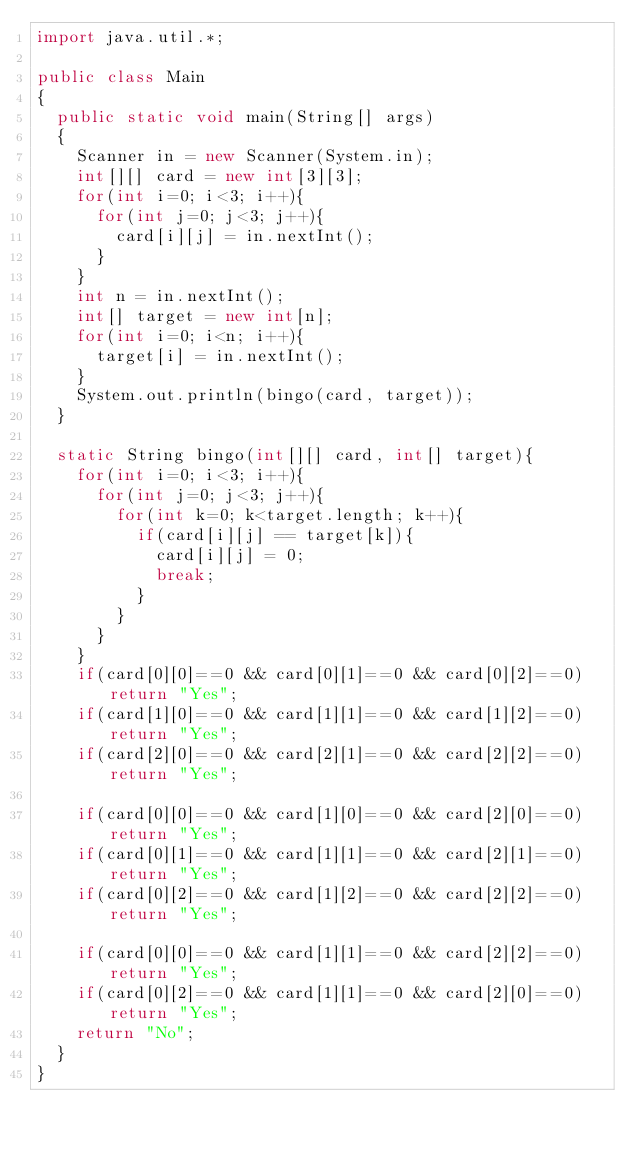<code> <loc_0><loc_0><loc_500><loc_500><_Java_>import java.util.*;

public class Main
{
  public static void main(String[] args)
  {
    Scanner in = new Scanner(System.in);
    int[][] card = new int[3][3];
    for(int i=0; i<3; i++){
      for(int j=0; j<3; j++){
        card[i][j] = in.nextInt();
      }
    }
    int n = in.nextInt();
    int[] target = new int[n];
    for(int i=0; i<n; i++){
      target[i] = in.nextInt();
    }
    System.out.println(bingo(card, target));
  }
  
  static String bingo(int[][] card, int[] target){
    for(int i=0; i<3; i++){
      for(int j=0; j<3; j++){
        for(int k=0; k<target.length; k++){
          if(card[i][j] == target[k]){
            card[i][j] = 0;
            break;
          }
        }
      }
    }
    if(card[0][0]==0 && card[0][1]==0 && card[0][2]==0) return "Yes";
    if(card[1][0]==0 && card[1][1]==0 && card[1][2]==0) return "Yes";
    if(card[2][0]==0 && card[2][1]==0 && card[2][2]==0) return "Yes";

    if(card[0][0]==0 && card[1][0]==0 && card[2][0]==0) return "Yes";
    if(card[0][1]==0 && card[1][1]==0 && card[2][1]==0) return "Yes";
    if(card[0][2]==0 && card[1][2]==0 && card[2][2]==0) return "Yes";

    if(card[0][0]==0 && card[1][1]==0 && card[2][2]==0) return "Yes";
    if(card[0][2]==0 && card[1][1]==0 && card[2][0]==0) return "Yes";
    return "No";
  }
}
</code> 